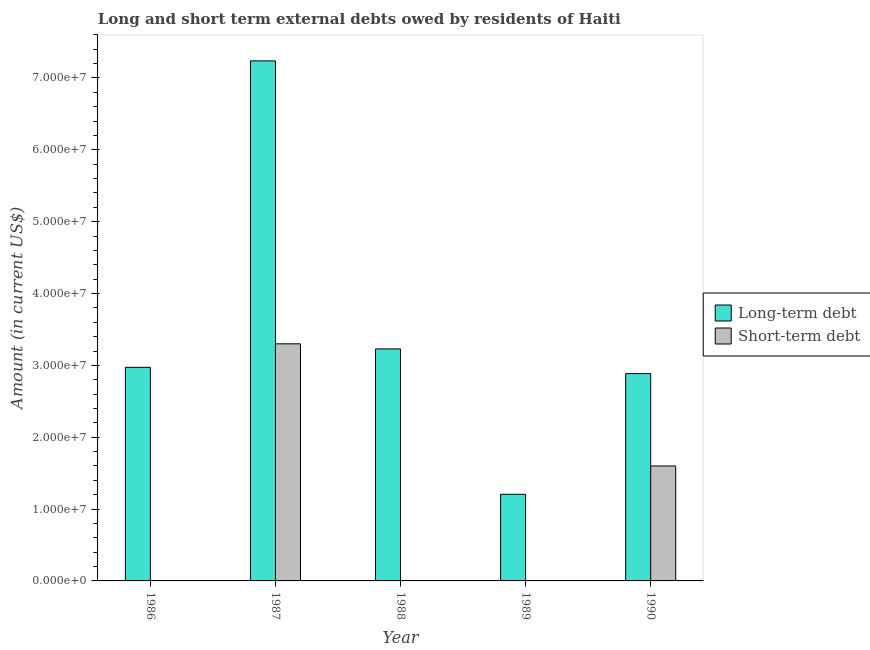Are the number of bars per tick equal to the number of legend labels?
Your answer should be very brief. No. What is the label of the 4th group of bars from the left?
Give a very brief answer. 1989. What is the long-term debts owed by residents in 1990?
Make the answer very short. 2.89e+07. Across all years, what is the maximum long-term debts owed by residents?
Provide a short and direct response. 7.24e+07. Across all years, what is the minimum long-term debts owed by residents?
Provide a short and direct response. 1.21e+07. In which year was the long-term debts owed by residents maximum?
Your answer should be very brief. 1987. What is the total long-term debts owed by residents in the graph?
Make the answer very short. 1.75e+08. What is the difference between the long-term debts owed by residents in 1989 and that in 1990?
Make the answer very short. -1.68e+07. What is the difference between the short-term debts owed by residents in 1986 and the long-term debts owed by residents in 1987?
Provide a succinct answer. -3.30e+07. What is the average long-term debts owed by residents per year?
Offer a terse response. 3.51e+07. In the year 1989, what is the difference between the long-term debts owed by residents and short-term debts owed by residents?
Offer a terse response. 0. In how many years, is the short-term debts owed by residents greater than 2000000 US$?
Your response must be concise. 2. What is the ratio of the long-term debts owed by residents in 1987 to that in 1988?
Provide a succinct answer. 2.24. Is the difference between the long-term debts owed by residents in 1986 and 1989 greater than the difference between the short-term debts owed by residents in 1986 and 1989?
Provide a succinct answer. No. What is the difference between the highest and the second highest long-term debts owed by residents?
Offer a very short reply. 4.01e+07. What is the difference between the highest and the lowest short-term debts owed by residents?
Provide a succinct answer. 3.30e+07. In how many years, is the long-term debts owed by residents greater than the average long-term debts owed by residents taken over all years?
Provide a short and direct response. 1. How many bars are there?
Your answer should be compact. 7. Are the values on the major ticks of Y-axis written in scientific E-notation?
Provide a succinct answer. Yes. Does the graph contain grids?
Provide a short and direct response. No. Where does the legend appear in the graph?
Your answer should be compact. Center right. How are the legend labels stacked?
Ensure brevity in your answer.  Vertical. What is the title of the graph?
Keep it short and to the point. Long and short term external debts owed by residents of Haiti. Does "Male population" appear as one of the legend labels in the graph?
Offer a very short reply. No. What is the label or title of the X-axis?
Make the answer very short. Year. What is the label or title of the Y-axis?
Provide a short and direct response. Amount (in current US$). What is the Amount (in current US$) of Long-term debt in 1986?
Offer a very short reply. 2.97e+07. What is the Amount (in current US$) in Short-term debt in 1986?
Ensure brevity in your answer.  0. What is the Amount (in current US$) in Long-term debt in 1987?
Your answer should be compact. 7.24e+07. What is the Amount (in current US$) in Short-term debt in 1987?
Ensure brevity in your answer.  3.30e+07. What is the Amount (in current US$) of Long-term debt in 1988?
Offer a very short reply. 3.23e+07. What is the Amount (in current US$) of Short-term debt in 1988?
Offer a terse response. 0. What is the Amount (in current US$) of Long-term debt in 1989?
Offer a terse response. 1.21e+07. What is the Amount (in current US$) of Short-term debt in 1989?
Ensure brevity in your answer.  0. What is the Amount (in current US$) in Long-term debt in 1990?
Give a very brief answer. 2.89e+07. What is the Amount (in current US$) in Short-term debt in 1990?
Offer a very short reply. 1.60e+07. Across all years, what is the maximum Amount (in current US$) of Long-term debt?
Your answer should be compact. 7.24e+07. Across all years, what is the maximum Amount (in current US$) in Short-term debt?
Your response must be concise. 3.30e+07. Across all years, what is the minimum Amount (in current US$) of Long-term debt?
Your answer should be very brief. 1.21e+07. Across all years, what is the minimum Amount (in current US$) in Short-term debt?
Give a very brief answer. 0. What is the total Amount (in current US$) in Long-term debt in the graph?
Offer a very short reply. 1.75e+08. What is the total Amount (in current US$) of Short-term debt in the graph?
Your response must be concise. 4.90e+07. What is the difference between the Amount (in current US$) in Long-term debt in 1986 and that in 1987?
Ensure brevity in your answer.  -4.27e+07. What is the difference between the Amount (in current US$) of Long-term debt in 1986 and that in 1988?
Make the answer very short. -2.56e+06. What is the difference between the Amount (in current US$) of Long-term debt in 1986 and that in 1989?
Keep it short and to the point. 1.77e+07. What is the difference between the Amount (in current US$) in Long-term debt in 1986 and that in 1990?
Your answer should be compact. 8.74e+05. What is the difference between the Amount (in current US$) of Long-term debt in 1987 and that in 1988?
Offer a terse response. 4.01e+07. What is the difference between the Amount (in current US$) in Long-term debt in 1987 and that in 1989?
Provide a short and direct response. 6.03e+07. What is the difference between the Amount (in current US$) in Long-term debt in 1987 and that in 1990?
Keep it short and to the point. 4.35e+07. What is the difference between the Amount (in current US$) of Short-term debt in 1987 and that in 1990?
Keep it short and to the point. 1.70e+07. What is the difference between the Amount (in current US$) in Long-term debt in 1988 and that in 1989?
Make the answer very short. 2.02e+07. What is the difference between the Amount (in current US$) of Long-term debt in 1988 and that in 1990?
Your answer should be very brief. 3.44e+06. What is the difference between the Amount (in current US$) in Long-term debt in 1989 and that in 1990?
Ensure brevity in your answer.  -1.68e+07. What is the difference between the Amount (in current US$) in Long-term debt in 1986 and the Amount (in current US$) in Short-term debt in 1987?
Keep it short and to the point. -3.27e+06. What is the difference between the Amount (in current US$) of Long-term debt in 1986 and the Amount (in current US$) of Short-term debt in 1990?
Provide a succinct answer. 1.37e+07. What is the difference between the Amount (in current US$) in Long-term debt in 1987 and the Amount (in current US$) in Short-term debt in 1990?
Offer a very short reply. 5.64e+07. What is the difference between the Amount (in current US$) in Long-term debt in 1988 and the Amount (in current US$) in Short-term debt in 1990?
Provide a short and direct response. 1.63e+07. What is the difference between the Amount (in current US$) in Long-term debt in 1989 and the Amount (in current US$) in Short-term debt in 1990?
Make the answer very short. -3.94e+06. What is the average Amount (in current US$) in Long-term debt per year?
Keep it short and to the point. 3.51e+07. What is the average Amount (in current US$) of Short-term debt per year?
Give a very brief answer. 9.80e+06. In the year 1987, what is the difference between the Amount (in current US$) of Long-term debt and Amount (in current US$) of Short-term debt?
Offer a very short reply. 3.94e+07. In the year 1990, what is the difference between the Amount (in current US$) in Long-term debt and Amount (in current US$) in Short-term debt?
Offer a very short reply. 1.29e+07. What is the ratio of the Amount (in current US$) of Long-term debt in 1986 to that in 1987?
Make the answer very short. 0.41. What is the ratio of the Amount (in current US$) of Long-term debt in 1986 to that in 1988?
Your answer should be very brief. 0.92. What is the ratio of the Amount (in current US$) of Long-term debt in 1986 to that in 1989?
Keep it short and to the point. 2.47. What is the ratio of the Amount (in current US$) of Long-term debt in 1986 to that in 1990?
Ensure brevity in your answer.  1.03. What is the ratio of the Amount (in current US$) of Long-term debt in 1987 to that in 1988?
Provide a succinct answer. 2.24. What is the ratio of the Amount (in current US$) of Long-term debt in 1987 to that in 1989?
Ensure brevity in your answer.  6. What is the ratio of the Amount (in current US$) of Long-term debt in 1987 to that in 1990?
Offer a very short reply. 2.51. What is the ratio of the Amount (in current US$) in Short-term debt in 1987 to that in 1990?
Provide a succinct answer. 2.06. What is the ratio of the Amount (in current US$) of Long-term debt in 1988 to that in 1989?
Keep it short and to the point. 2.68. What is the ratio of the Amount (in current US$) of Long-term debt in 1988 to that in 1990?
Your answer should be compact. 1.12. What is the ratio of the Amount (in current US$) in Long-term debt in 1989 to that in 1990?
Offer a terse response. 0.42. What is the difference between the highest and the second highest Amount (in current US$) in Long-term debt?
Your answer should be very brief. 4.01e+07. What is the difference between the highest and the lowest Amount (in current US$) in Long-term debt?
Provide a succinct answer. 6.03e+07. What is the difference between the highest and the lowest Amount (in current US$) in Short-term debt?
Your answer should be very brief. 3.30e+07. 